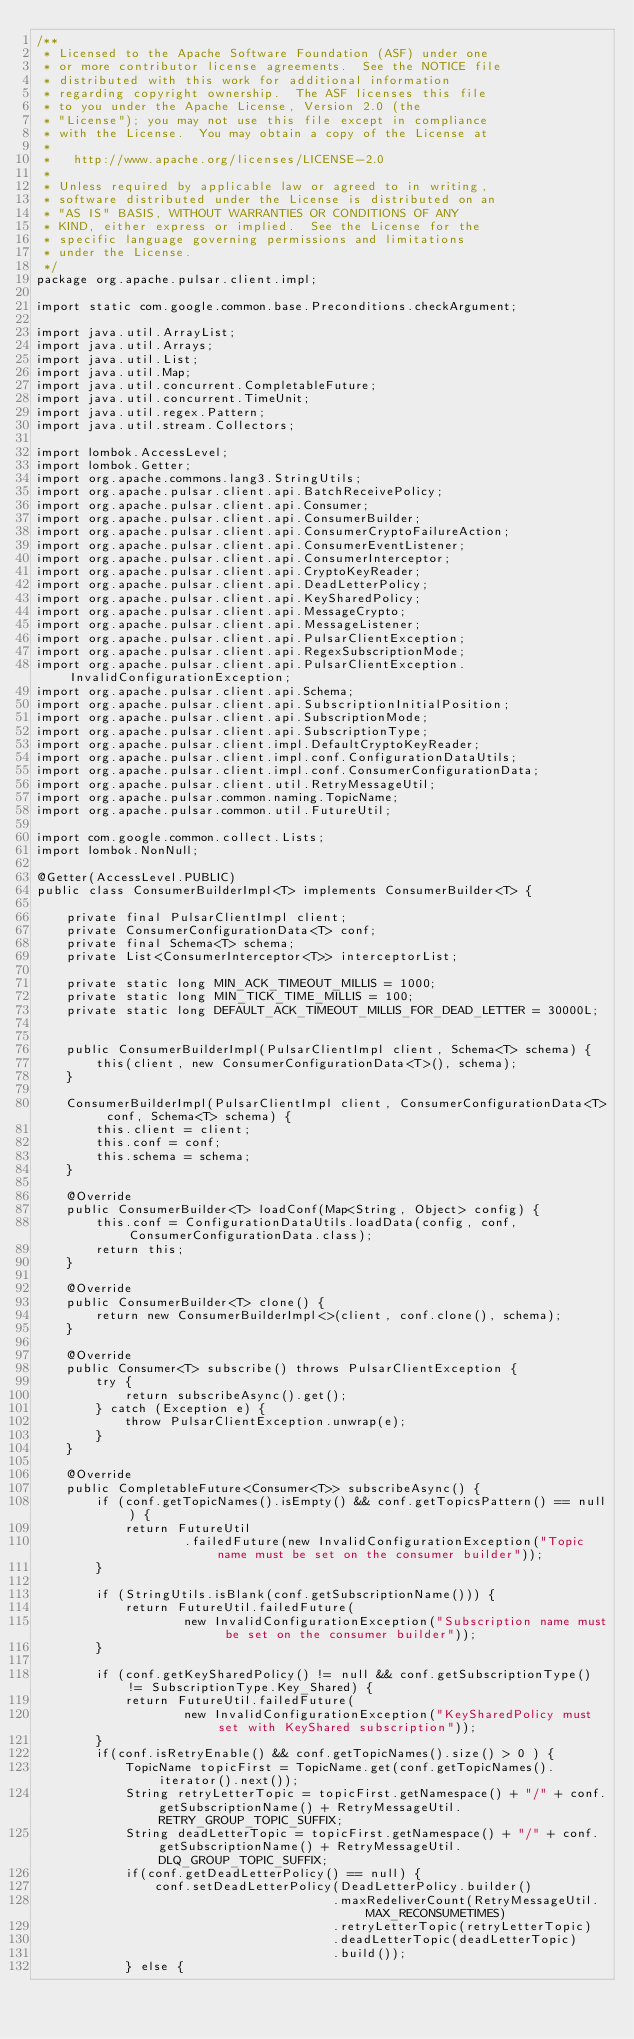<code> <loc_0><loc_0><loc_500><loc_500><_Java_>/**
 * Licensed to the Apache Software Foundation (ASF) under one
 * or more contributor license agreements.  See the NOTICE file
 * distributed with this work for additional information
 * regarding copyright ownership.  The ASF licenses this file
 * to you under the Apache License, Version 2.0 (the
 * "License"); you may not use this file except in compliance
 * with the License.  You may obtain a copy of the License at
 *
 *   http://www.apache.org/licenses/LICENSE-2.0
 *
 * Unless required by applicable law or agreed to in writing,
 * software distributed under the License is distributed on an
 * "AS IS" BASIS, WITHOUT WARRANTIES OR CONDITIONS OF ANY
 * KIND, either express or implied.  See the License for the
 * specific language governing permissions and limitations
 * under the License.
 */
package org.apache.pulsar.client.impl;

import static com.google.common.base.Preconditions.checkArgument;

import java.util.ArrayList;
import java.util.Arrays;
import java.util.List;
import java.util.Map;
import java.util.concurrent.CompletableFuture;
import java.util.concurrent.TimeUnit;
import java.util.regex.Pattern;
import java.util.stream.Collectors;

import lombok.AccessLevel;
import lombok.Getter;
import org.apache.commons.lang3.StringUtils;
import org.apache.pulsar.client.api.BatchReceivePolicy;
import org.apache.pulsar.client.api.Consumer;
import org.apache.pulsar.client.api.ConsumerBuilder;
import org.apache.pulsar.client.api.ConsumerCryptoFailureAction;
import org.apache.pulsar.client.api.ConsumerEventListener;
import org.apache.pulsar.client.api.ConsumerInterceptor;
import org.apache.pulsar.client.api.CryptoKeyReader;
import org.apache.pulsar.client.api.DeadLetterPolicy;
import org.apache.pulsar.client.api.KeySharedPolicy;
import org.apache.pulsar.client.api.MessageCrypto;
import org.apache.pulsar.client.api.MessageListener;
import org.apache.pulsar.client.api.PulsarClientException;
import org.apache.pulsar.client.api.RegexSubscriptionMode;
import org.apache.pulsar.client.api.PulsarClientException.InvalidConfigurationException;
import org.apache.pulsar.client.api.Schema;
import org.apache.pulsar.client.api.SubscriptionInitialPosition;
import org.apache.pulsar.client.api.SubscriptionMode;
import org.apache.pulsar.client.api.SubscriptionType;
import org.apache.pulsar.client.impl.DefaultCryptoKeyReader;
import org.apache.pulsar.client.impl.conf.ConfigurationDataUtils;
import org.apache.pulsar.client.impl.conf.ConsumerConfigurationData;
import org.apache.pulsar.client.util.RetryMessageUtil;
import org.apache.pulsar.common.naming.TopicName;
import org.apache.pulsar.common.util.FutureUtil;

import com.google.common.collect.Lists;
import lombok.NonNull;

@Getter(AccessLevel.PUBLIC)
public class ConsumerBuilderImpl<T> implements ConsumerBuilder<T> {

    private final PulsarClientImpl client;
    private ConsumerConfigurationData<T> conf;
    private final Schema<T> schema;
    private List<ConsumerInterceptor<T>> interceptorList;

    private static long MIN_ACK_TIMEOUT_MILLIS = 1000;
    private static long MIN_TICK_TIME_MILLIS = 100;
    private static long DEFAULT_ACK_TIMEOUT_MILLIS_FOR_DEAD_LETTER = 30000L;


    public ConsumerBuilderImpl(PulsarClientImpl client, Schema<T> schema) {
        this(client, new ConsumerConfigurationData<T>(), schema);
    }

    ConsumerBuilderImpl(PulsarClientImpl client, ConsumerConfigurationData<T> conf, Schema<T> schema) {
        this.client = client;
        this.conf = conf;
        this.schema = schema;
    }

    @Override
    public ConsumerBuilder<T> loadConf(Map<String, Object> config) {
        this.conf = ConfigurationDataUtils.loadData(config, conf, ConsumerConfigurationData.class);
        return this;
    }

    @Override
    public ConsumerBuilder<T> clone() {
        return new ConsumerBuilderImpl<>(client, conf.clone(), schema);
    }

    @Override
    public Consumer<T> subscribe() throws PulsarClientException {
        try {
            return subscribeAsync().get();
        } catch (Exception e) {
            throw PulsarClientException.unwrap(e);
        }
    }

    @Override
    public CompletableFuture<Consumer<T>> subscribeAsync() {
        if (conf.getTopicNames().isEmpty() && conf.getTopicsPattern() == null) {
            return FutureUtil
                    .failedFuture(new InvalidConfigurationException("Topic name must be set on the consumer builder"));
        }

        if (StringUtils.isBlank(conf.getSubscriptionName())) {
            return FutureUtil.failedFuture(
                    new InvalidConfigurationException("Subscription name must be set on the consumer builder"));
        }

        if (conf.getKeySharedPolicy() != null && conf.getSubscriptionType() != SubscriptionType.Key_Shared) {
            return FutureUtil.failedFuture(
                    new InvalidConfigurationException("KeySharedPolicy must set with KeyShared subscription"));
        }
        if(conf.isRetryEnable() && conf.getTopicNames().size() > 0 ) {
            TopicName topicFirst = TopicName.get(conf.getTopicNames().iterator().next());
            String retryLetterTopic = topicFirst.getNamespace() + "/" + conf.getSubscriptionName() + RetryMessageUtil.RETRY_GROUP_TOPIC_SUFFIX;
            String deadLetterTopic = topicFirst.getNamespace() + "/" + conf.getSubscriptionName() + RetryMessageUtil.DLQ_GROUP_TOPIC_SUFFIX;
            if(conf.getDeadLetterPolicy() == null) {
                conf.setDeadLetterPolicy(DeadLetterPolicy.builder()
                                        .maxRedeliverCount(RetryMessageUtil.MAX_RECONSUMETIMES)
                                        .retryLetterTopic(retryLetterTopic)
                                        .deadLetterTopic(deadLetterTopic)
                                        .build());
            } else {</code> 